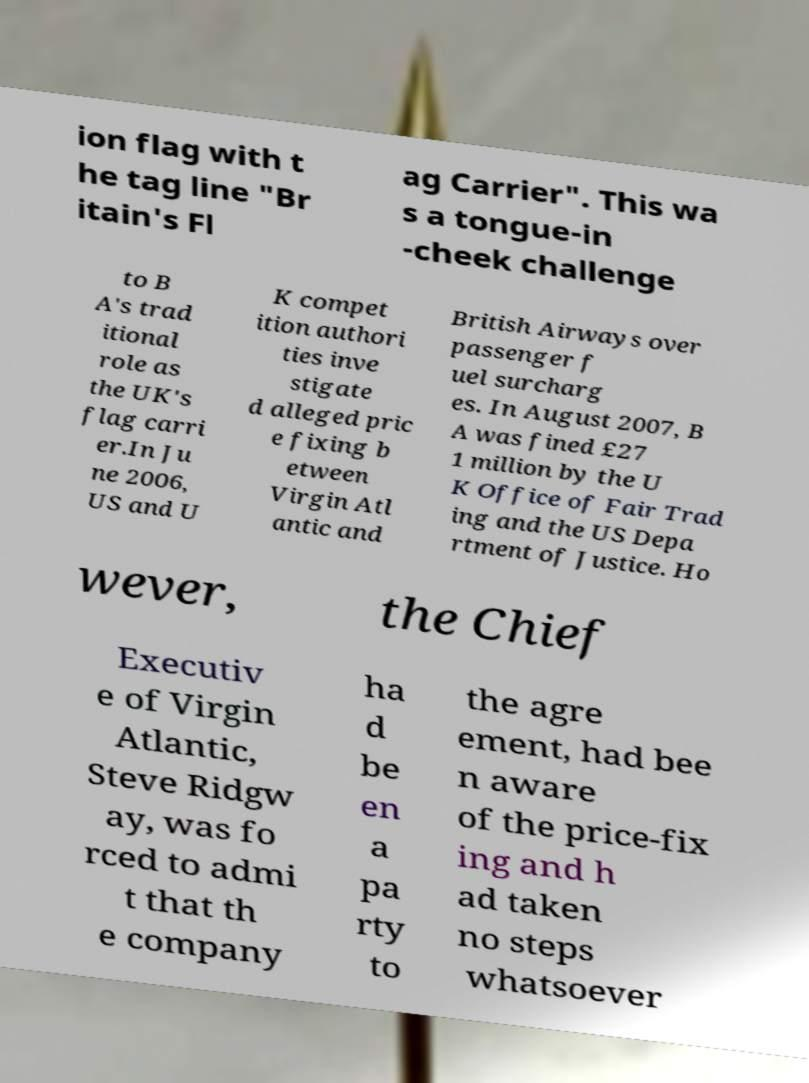Could you assist in decoding the text presented in this image and type it out clearly? ion flag with t he tag line "Br itain's Fl ag Carrier". This wa s a tongue-in -cheek challenge to B A's trad itional role as the UK's flag carri er.In Ju ne 2006, US and U K compet ition authori ties inve stigate d alleged pric e fixing b etween Virgin Atl antic and British Airways over passenger f uel surcharg es. In August 2007, B A was fined £27 1 million by the U K Office of Fair Trad ing and the US Depa rtment of Justice. Ho wever, the Chief Executiv e of Virgin Atlantic, Steve Ridgw ay, was fo rced to admi t that th e company ha d be en a pa rty to the agre ement, had bee n aware of the price-fix ing and h ad taken no steps whatsoever 